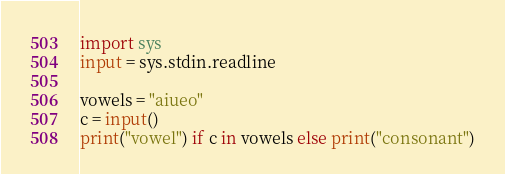<code> <loc_0><loc_0><loc_500><loc_500><_Python_>import sys
input = sys.stdin.readline

vowels = "aiueo"
c = input()
print("vowel") if c in vowels else print("consonant")</code> 